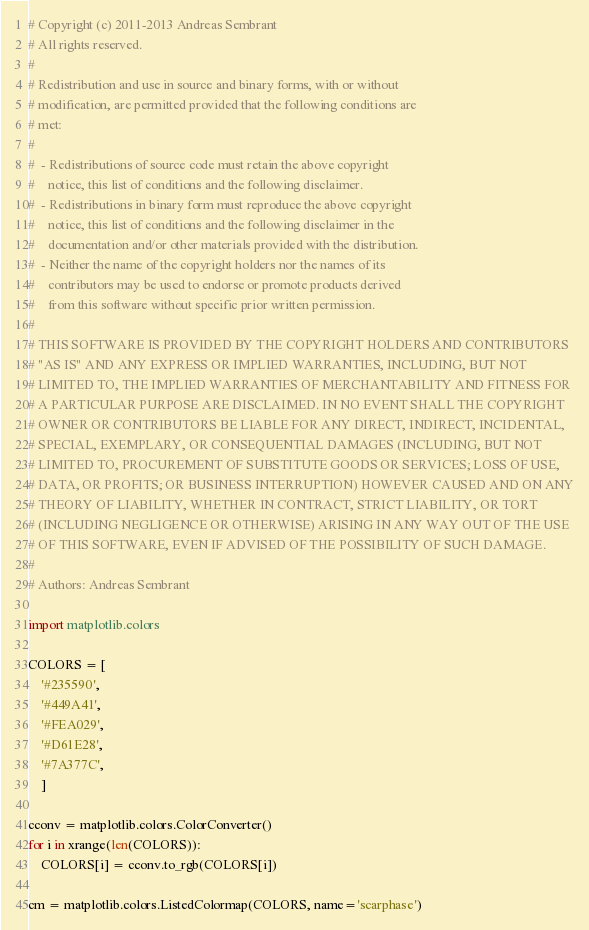<code> <loc_0><loc_0><loc_500><loc_500><_Python_># Copyright (c) 2011-2013 Andreas Sembrant
# All rights reserved.
#
# Redistribution and use in source and binary forms, with or without
# modification, are permitted provided that the following conditions are
# met:
#
#  - Redistributions of source code must retain the above copyright
#    notice, this list of conditions and the following disclaimer.
#  - Redistributions in binary form must reproduce the above copyright
#    notice, this list of conditions and the following disclaimer in the
#    documentation and/or other materials provided with the distribution.
#  - Neither the name of the copyright holders nor the names of its
#    contributors may be used to endorse or promote products derived
#    from this software without specific prior written permission.
#
# THIS SOFTWARE IS PROVIDED BY THE COPYRIGHT HOLDERS AND CONTRIBUTORS
# "AS IS" AND ANY EXPRESS OR IMPLIED WARRANTIES, INCLUDING, BUT NOT
# LIMITED TO, THE IMPLIED WARRANTIES OF MERCHANTABILITY AND FITNESS FOR
# A PARTICULAR PURPOSE ARE DISCLAIMED. IN NO EVENT SHALL THE COPYRIGHT
# OWNER OR CONTRIBUTORS BE LIABLE FOR ANY DIRECT, INDIRECT, INCIDENTAL,
# SPECIAL, EXEMPLARY, OR CONSEQUENTIAL DAMAGES (INCLUDING, BUT NOT
# LIMITED TO, PROCUREMENT OF SUBSTITUTE GOODS OR SERVICES; LOSS OF USE,
# DATA, OR PROFITS; OR BUSINESS INTERRUPTION) HOWEVER CAUSED AND ON ANY
# THEORY OF LIABILITY, WHETHER IN CONTRACT, STRICT LIABILITY, OR TORT
# (INCLUDING NEGLIGENCE OR OTHERWISE) ARISING IN ANY WAY OUT OF THE USE
# OF THIS SOFTWARE, EVEN IF ADVISED OF THE POSSIBILITY OF SUCH DAMAGE.
#
# Authors: Andreas Sembrant

import matplotlib.colors

COLORS = [
    '#235590',
    '#449A41',
    '#FEA029',
    '#D61E28',
    '#7A377C',
    ]

cconv = matplotlib.colors.ColorConverter()
for i in xrange(len(COLORS)):
    COLORS[i] = cconv.to_rgb(COLORS[i])

cm = matplotlib.colors.ListedColormap(COLORS, name='scarphase')


</code> 